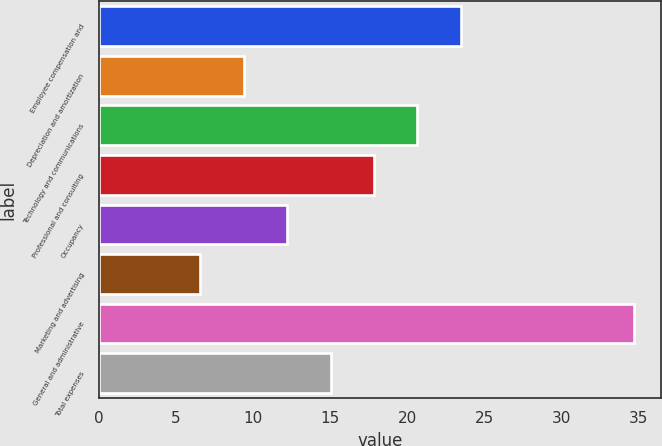Convert chart to OTSL. <chart><loc_0><loc_0><loc_500><loc_500><bar_chart><fcel>Employee compensation and<fcel>Depreciation and amortization<fcel>Technology and communications<fcel>Professional and consulting<fcel>Occupancy<fcel>Marketing and advertising<fcel>General and administrative<fcel>Total expenses<nl><fcel>23.46<fcel>9.41<fcel>20.65<fcel>17.84<fcel>12.22<fcel>6.6<fcel>34.7<fcel>15.03<nl></chart> 